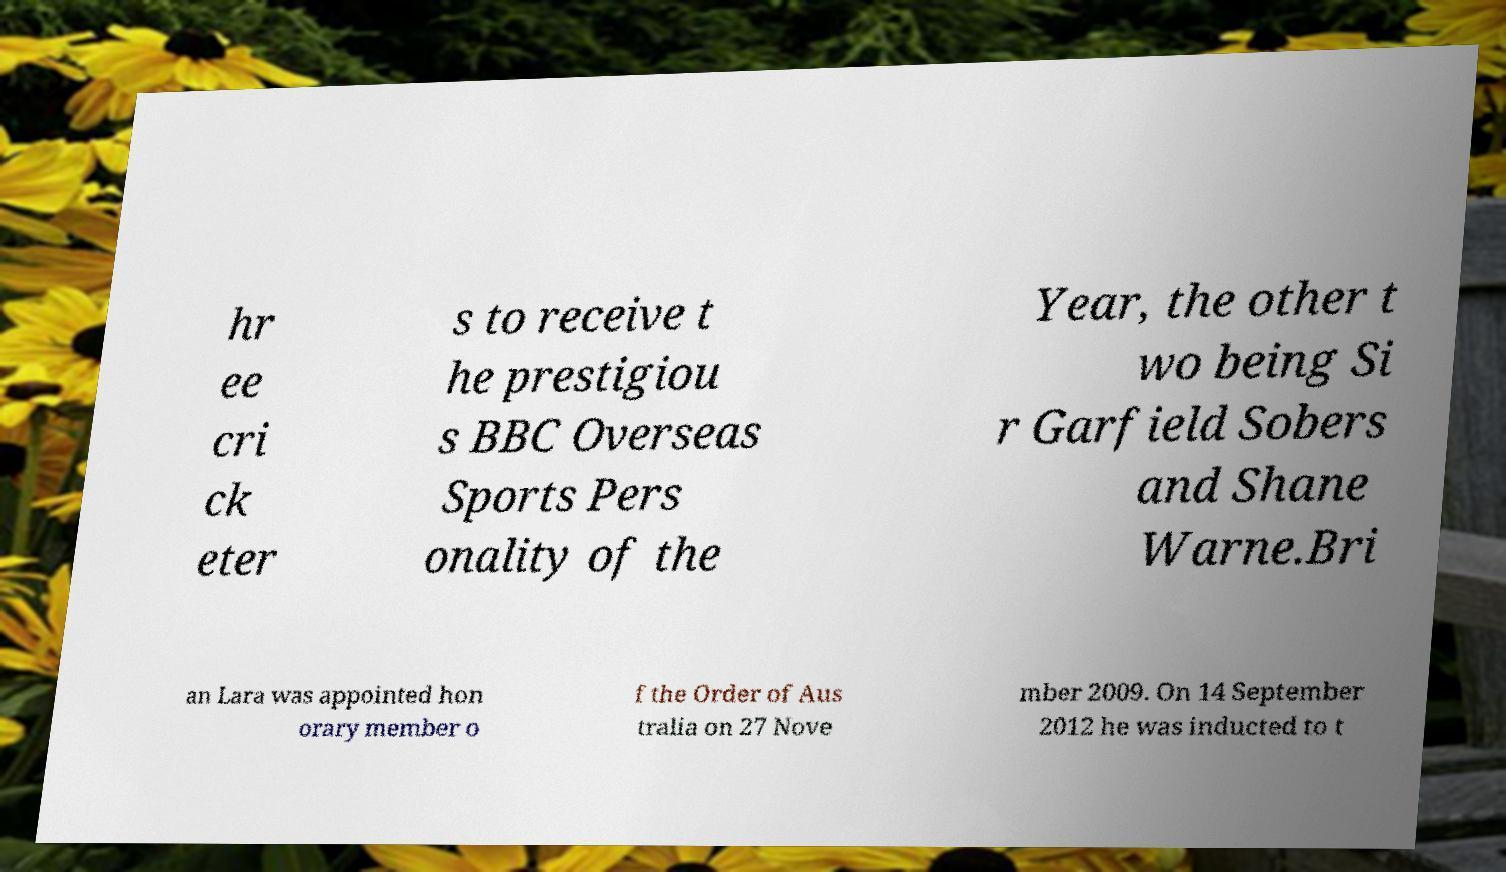What messages or text are displayed in this image? I need them in a readable, typed format. hr ee cri ck eter s to receive t he prestigiou s BBC Overseas Sports Pers onality of the Year, the other t wo being Si r Garfield Sobers and Shane Warne.Bri an Lara was appointed hon orary member o f the Order of Aus tralia on 27 Nove mber 2009. On 14 September 2012 he was inducted to t 